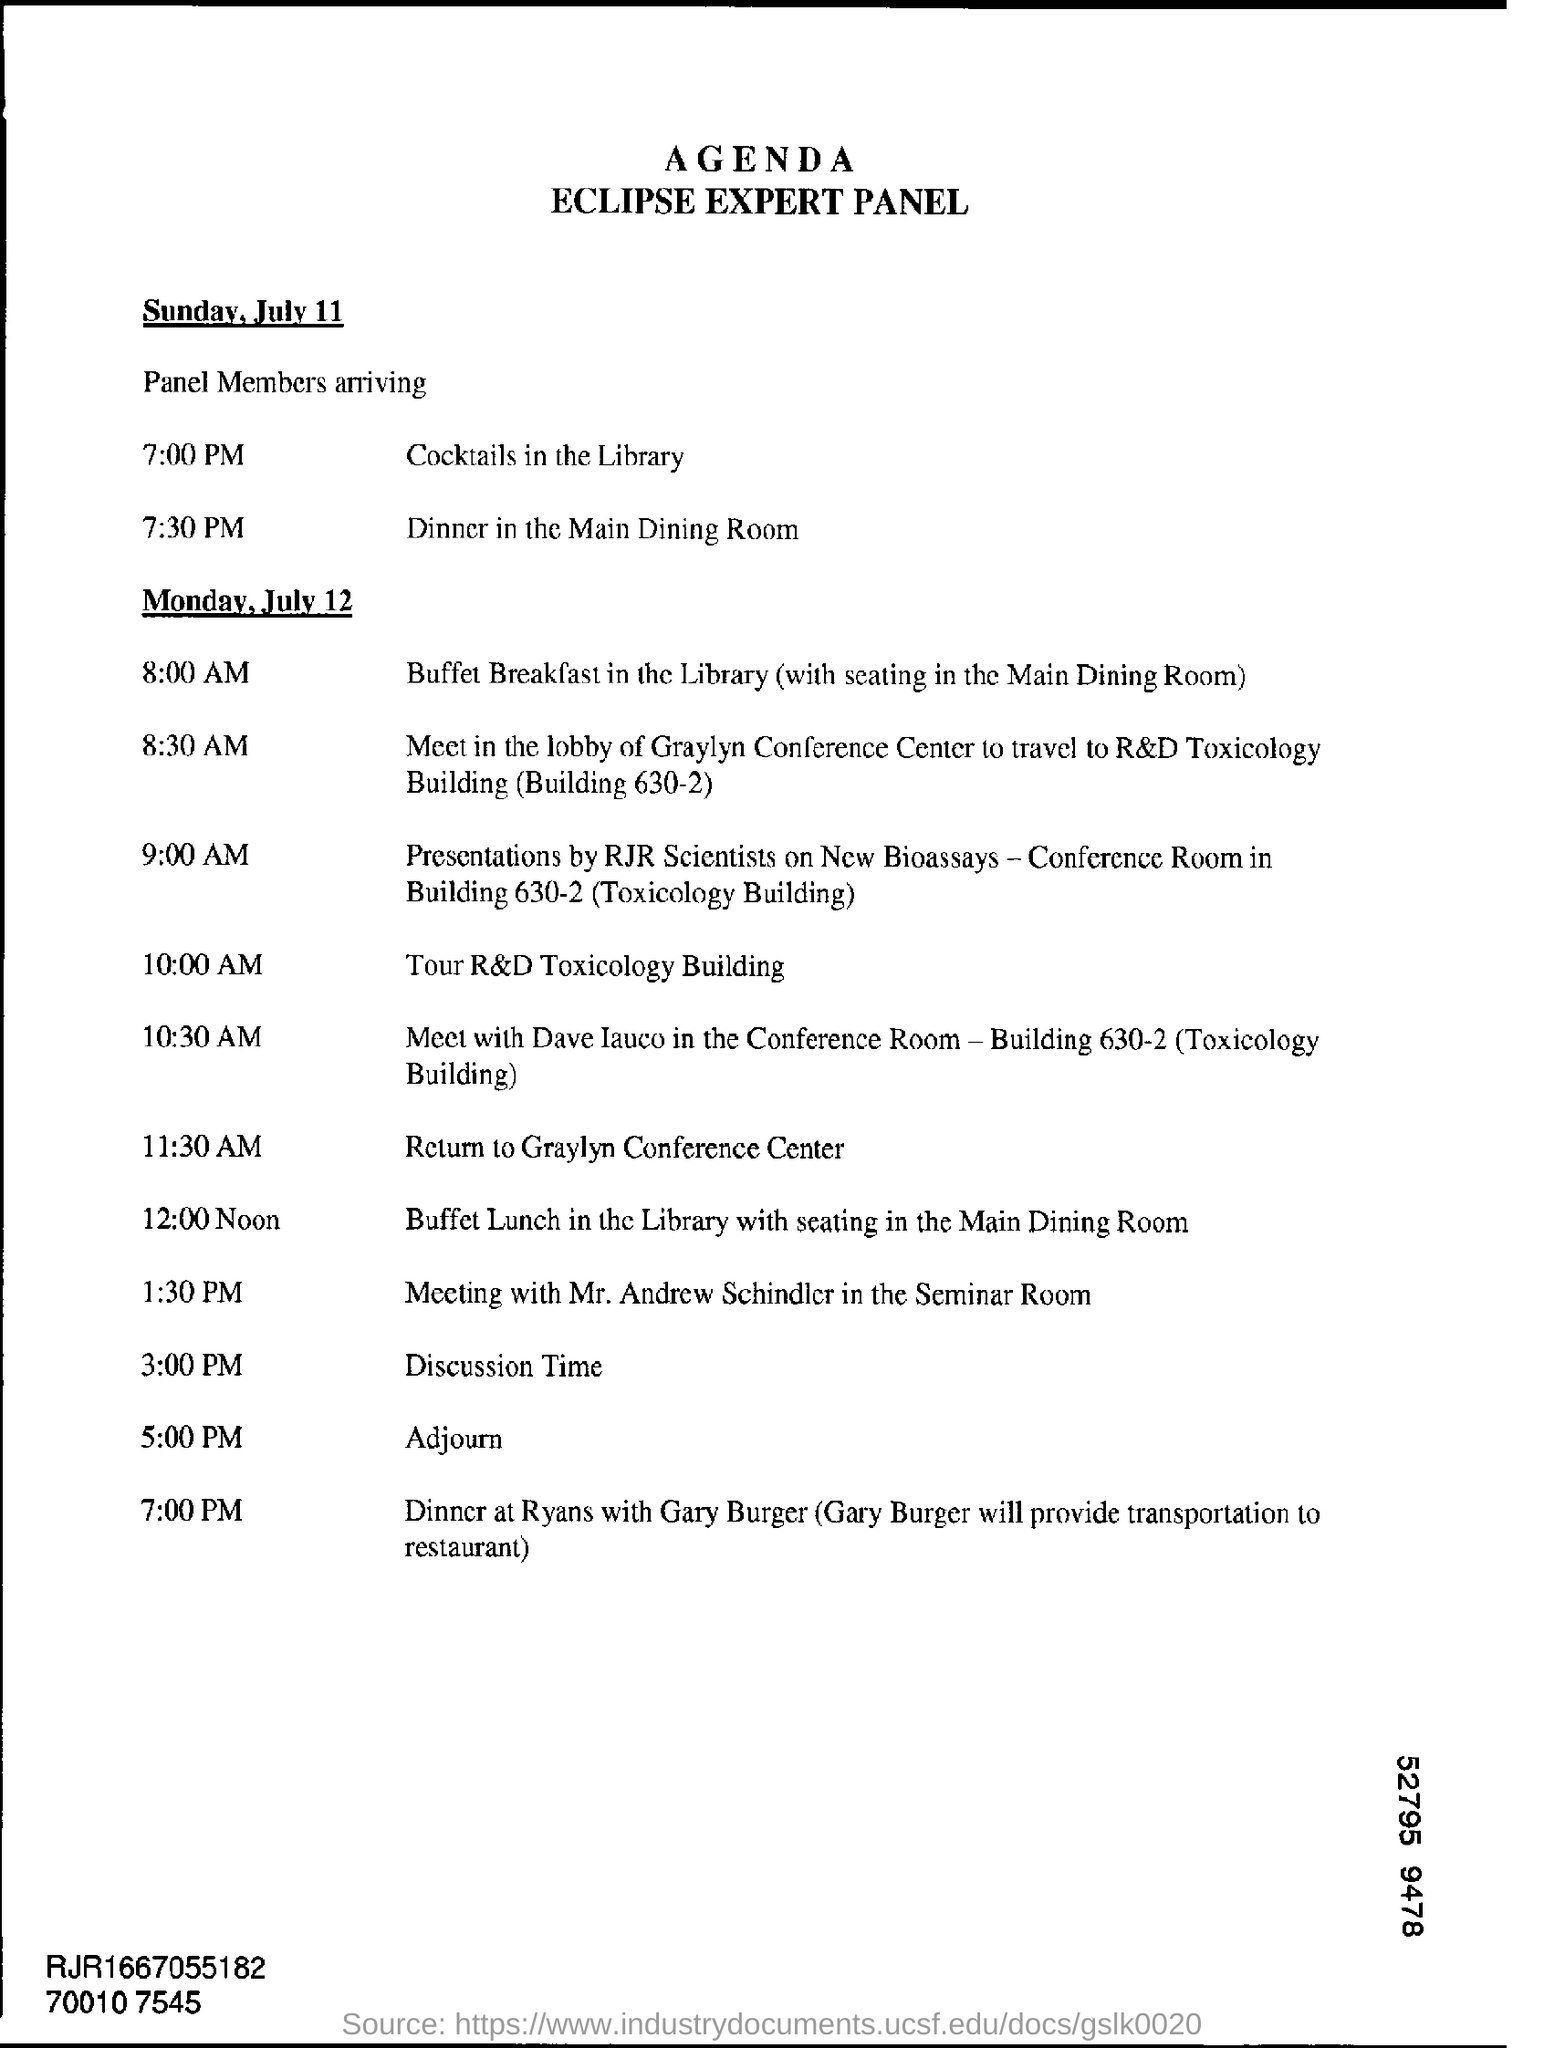Highlight a few significant elements in this photo. The name of the panel in Eclipse is the Expert Panel. On July 12, a meeting with Mr. Andrew Schindler will take place in the Seminar Room. 